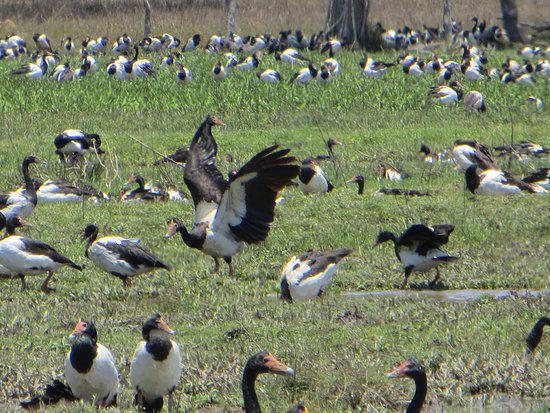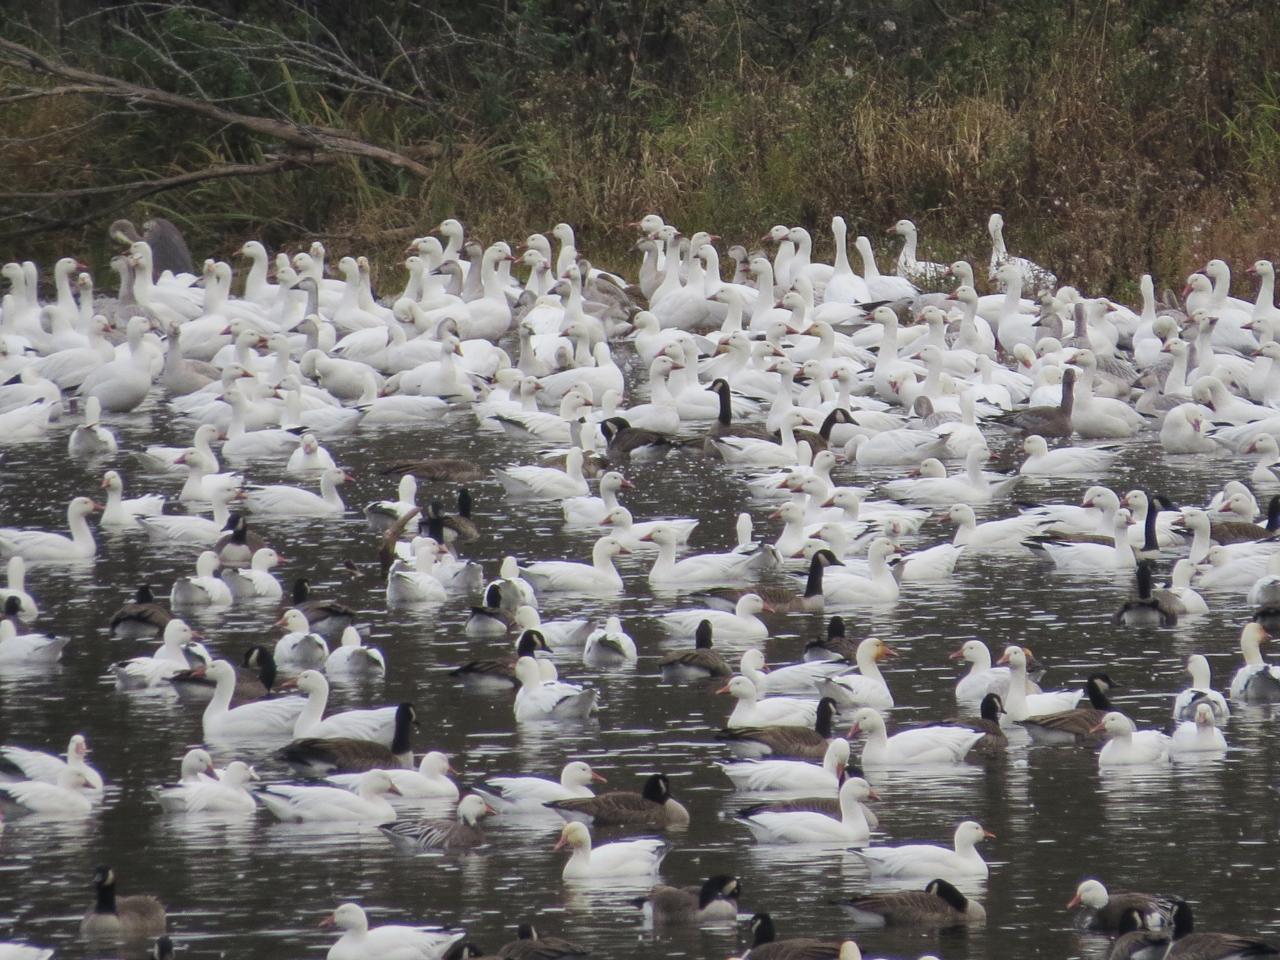The first image is the image on the left, the second image is the image on the right. Evaluate the accuracy of this statement regarding the images: "The birds in the image on the right are primarily white.". Is it true? Answer yes or no. Yes. The first image is the image on the left, the second image is the image on the right. Analyze the images presented: Is the assertion "Someone is in the field with the animals." valid? Answer yes or no. No. 